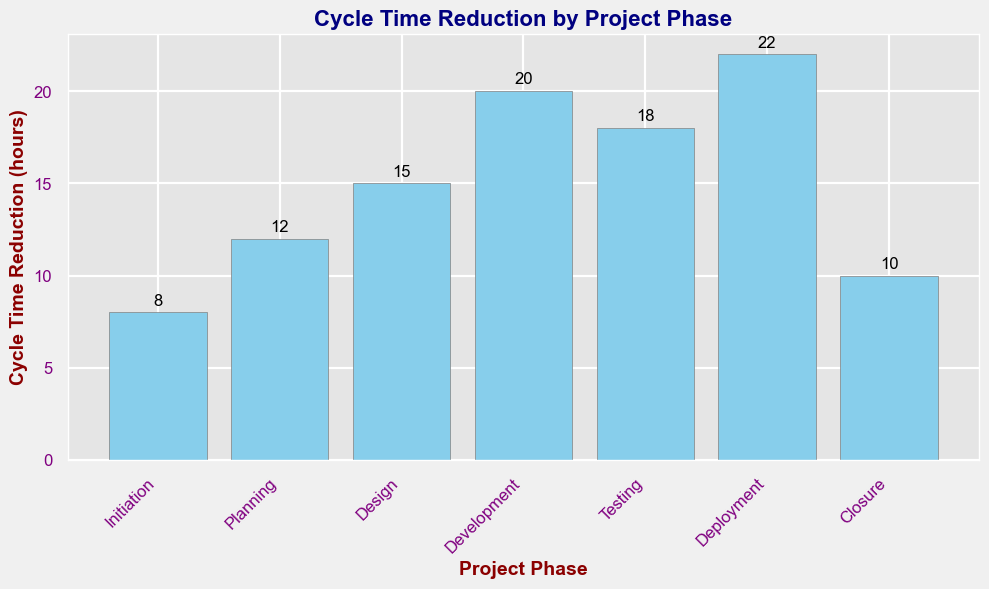What is the project phase with the highest cycle time reduction? The 'Deployment' phase has the highest cycle time reduction of 22 hours as shown by the tallest bar in the chart.
Answer: Deployment Which project phase has the lowest cycle time reduction? The 'Initiation' phase has the lowest cycle time reduction of 8 hours as indicated by the shortest bar.
Answer: Initiation What is the total cycle time reduction across all project phases? Sum the cycle time reduction values for all phases: 8 (Initiation) + 12 (Planning) + 15 (Design) + 20 (Development) + 18 (Testing) + 22 (Deployment) + 10 (Closure) = 105 hours.
Answer: 105 hours How much higher is the cycle time reduction in Deployment compared to Closure? Subtract the cycle time reduction in Closure from that in Deployment: 22 (Deployment) - 10 (Closure) = 12 hours.
Answer: 12 hours Which project phase has a cycle time reduction closest to the median value? Arrange the values: 8, 10, 12, 15, 18, 20, 22. The median value is 15 (Design), hence the 'Design' phase has the cycle time reduction closest to the median.
Answer: Design Which two consecutive project phases show the largest increase in cycle time reduction? Calculate the differences between consecutive phases: Planning - Initiation = 4, Design - Planning = 3, Development - Design = 5, Testing - Development = -2, Deployment - Testing = 4, Closure - Deployment = -12. The largest increase is from Design to Development with an increase of 5 hours.
Answer: Design to Development How much more time is reduced in the Testing phase compared to the Initiation phase? Subtract the cycle time reduction in Initiation from that in Testing: 18 (Testing) - 8 (Initiation) = 10 hours.
Answer: 10 hours Which phase sees more cycle time reduction, Design or Testing? Compare the values: Design (15 hours) vs. Testing (18 hours). The Testing phase has more cycle time reduction.
Answer: Testing What is the average cycle time reduction per phase? Calculate the average by dividing the total cycle time reduction by the number of phases: 105 hours / 7 phases = 15 hours/phase.
Answer: 15 hours/phase Is the cycle time reduction in the Development phase greater than the sum of the cycle time reductions in Initiation and Design phases? Sum the cycle time reductions of Initiation and Design: 8 (Initiation) + 15 (Design) = 23 hours. Compare with Development: 20 (Development). Development (20 hours) is less than the sum (23 hours).
Answer: No 